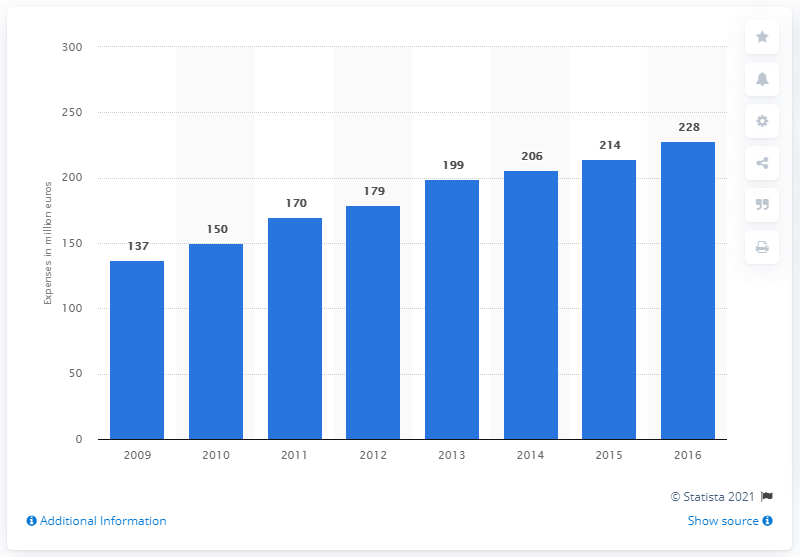Identify some key points in this picture. In 2016, Pirelli spent 228 million euros on research and development. In the fiscal year of 2016, Pirelli spent 228 million on research and development. 